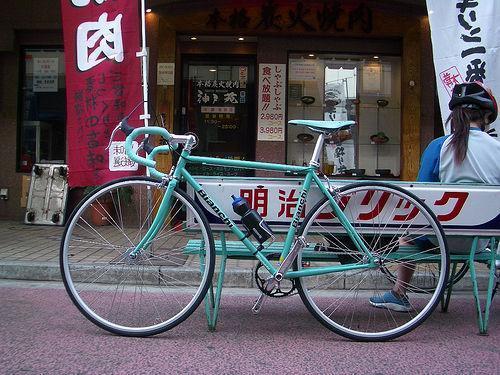How many benches are in the picture?
Give a very brief answer. 2. How many bicycles can you see?
Give a very brief answer. 1. How many cars behind the truck?
Give a very brief answer. 0. 